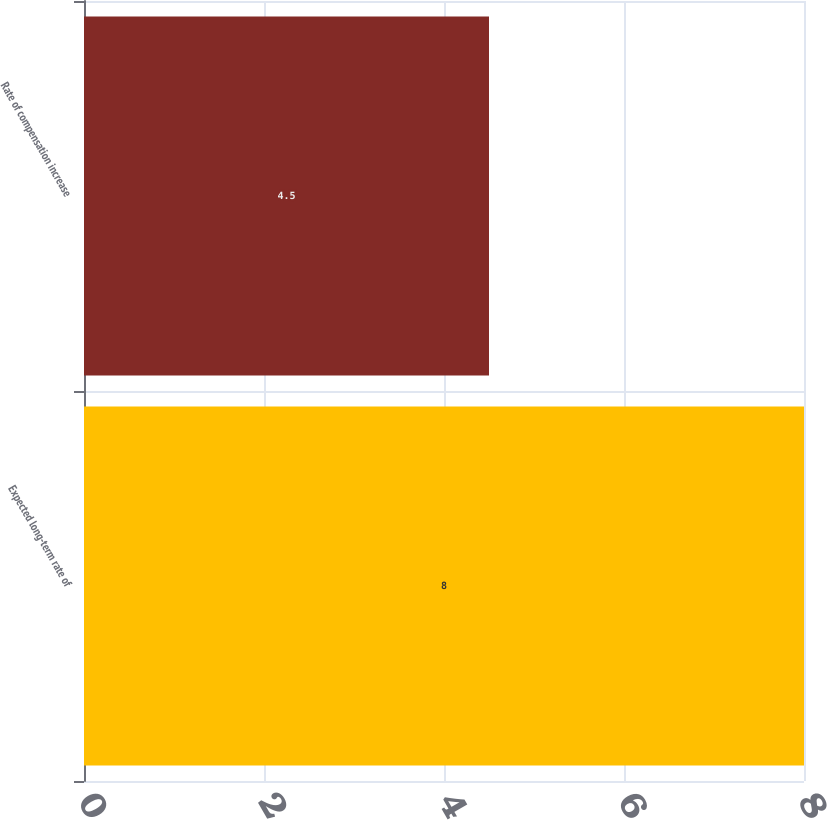Convert chart to OTSL. <chart><loc_0><loc_0><loc_500><loc_500><bar_chart><fcel>Expected long-term rate of<fcel>Rate of compensation increase<nl><fcel>8<fcel>4.5<nl></chart> 